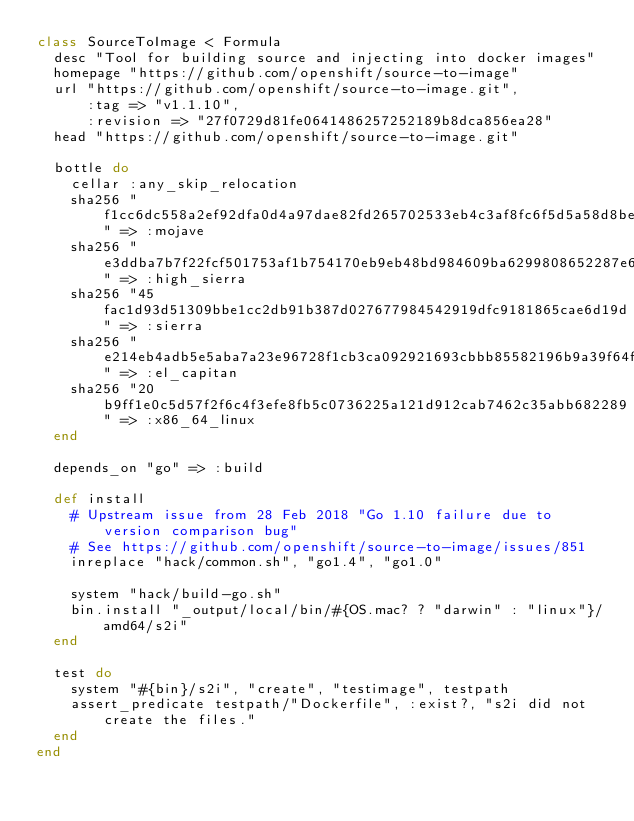Convert code to text. <code><loc_0><loc_0><loc_500><loc_500><_Ruby_>class SourceToImage < Formula
  desc "Tool for building source and injecting into docker images"
  homepage "https://github.com/openshift/source-to-image"
  url "https://github.com/openshift/source-to-image.git",
      :tag => "v1.1.10",
      :revision => "27f0729d81fe0641486257252189b8dca856ea28"
  head "https://github.com/openshift/source-to-image.git"

  bottle do
    cellar :any_skip_relocation
    sha256 "f1cc6dc558a2ef92dfa0d4a97dae82fd265702533eb4c3af8fc6f5d5a58d8be3" => :mojave
    sha256 "e3ddba7b7f22fcf501753af1b754170eb9eb48bd984609ba6299808652287e6e" => :high_sierra
    sha256 "45fac1d93d51309bbe1cc2db91b387d027677984542919dfc9181865cae6d19d" => :sierra
    sha256 "e214eb4adb5e5aba7a23e96728f1cb3ca092921693cbbb85582196b9a39f64f4" => :el_capitan
    sha256 "20b9ff1e0c5d57f2f6c4f3efe8fb5c0736225a121d912cab7462c35abb682289" => :x86_64_linux
  end

  depends_on "go" => :build

  def install
    # Upstream issue from 28 Feb 2018 "Go 1.10 failure due to version comparison bug"
    # See https://github.com/openshift/source-to-image/issues/851
    inreplace "hack/common.sh", "go1.4", "go1.0"

    system "hack/build-go.sh"
    bin.install "_output/local/bin/#{OS.mac? ? "darwin" : "linux"}/amd64/s2i"
  end

  test do
    system "#{bin}/s2i", "create", "testimage", testpath
    assert_predicate testpath/"Dockerfile", :exist?, "s2i did not create the files."
  end
end
</code> 